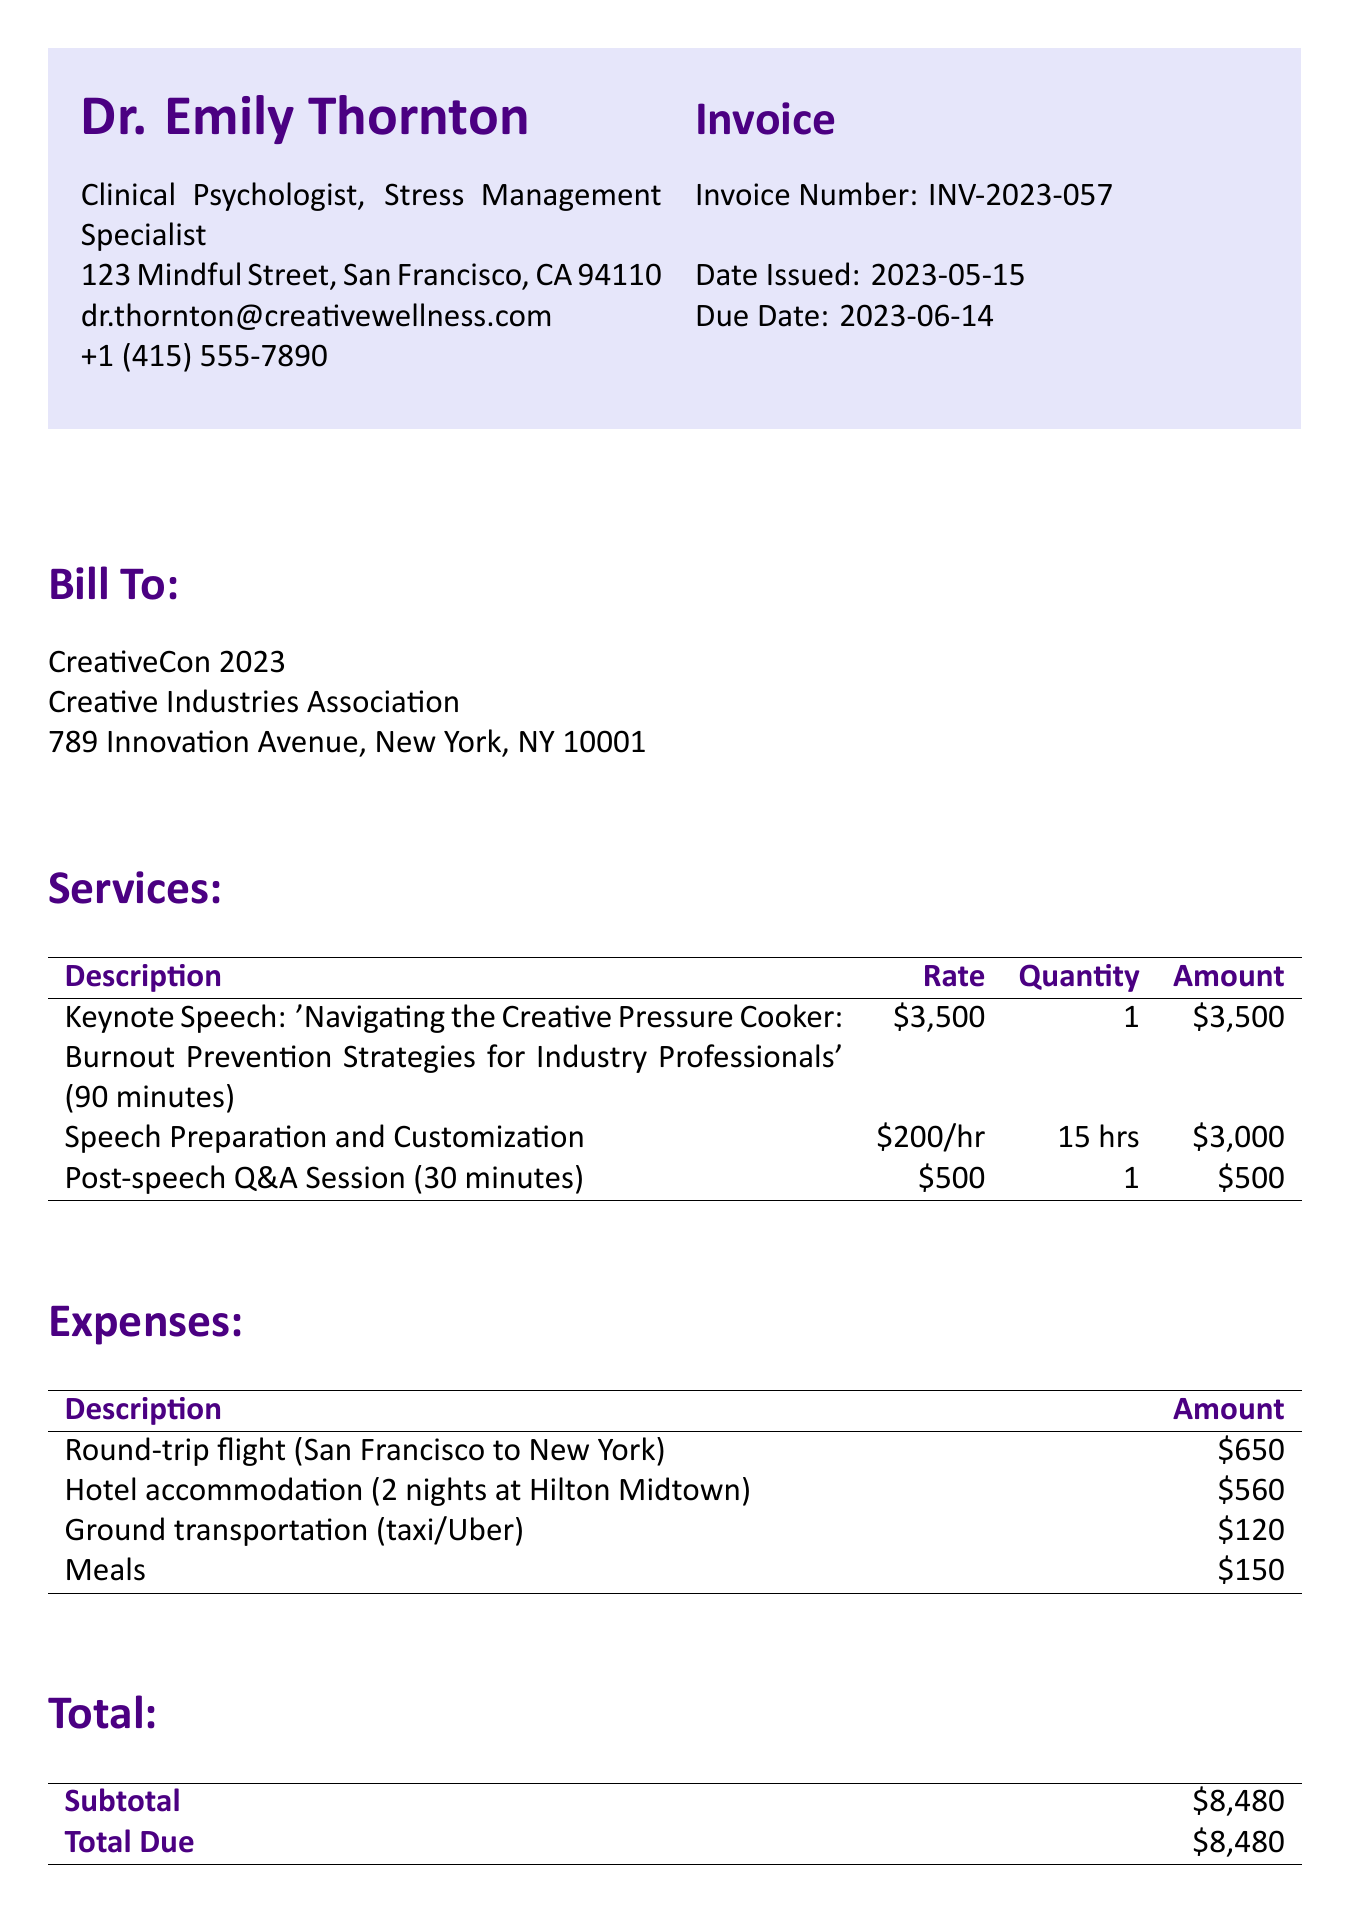what is the invoice number? The invoice number is listed in the invoice details section.
Answer: INV-2023-057 who is the client organization? The client organization is specifically mentioned in the client info section.
Answer: Creative Industries Association how much is the keynote speech fee? The fee for the keynote speech can be found in the services section.
Answer: $3,500 what is the total amount due? The total amount due is calculated based on the subtotal in the total section.
Answer: $8,480 how many hours were spent on speech preparation? The hours for speech preparation are provided in the services section.
Answer: 15 hours what is the due date of the invoice? The due date is specified in the invoice details section.
Answer: June 14, 2023 what type of payment methods are accepted? The invoice lists the available payment methods at the bottom of the document.
Answer: Bank Transfer and Check what is the amount for meals? The amount for meals is detailed in the expenses section of the document.
Answer: $150 what is the psychologist's title? The psychologist's title is mentioned in the psychologist info section.
Answer: Clinical Psychologist, Stress Management Specialist 